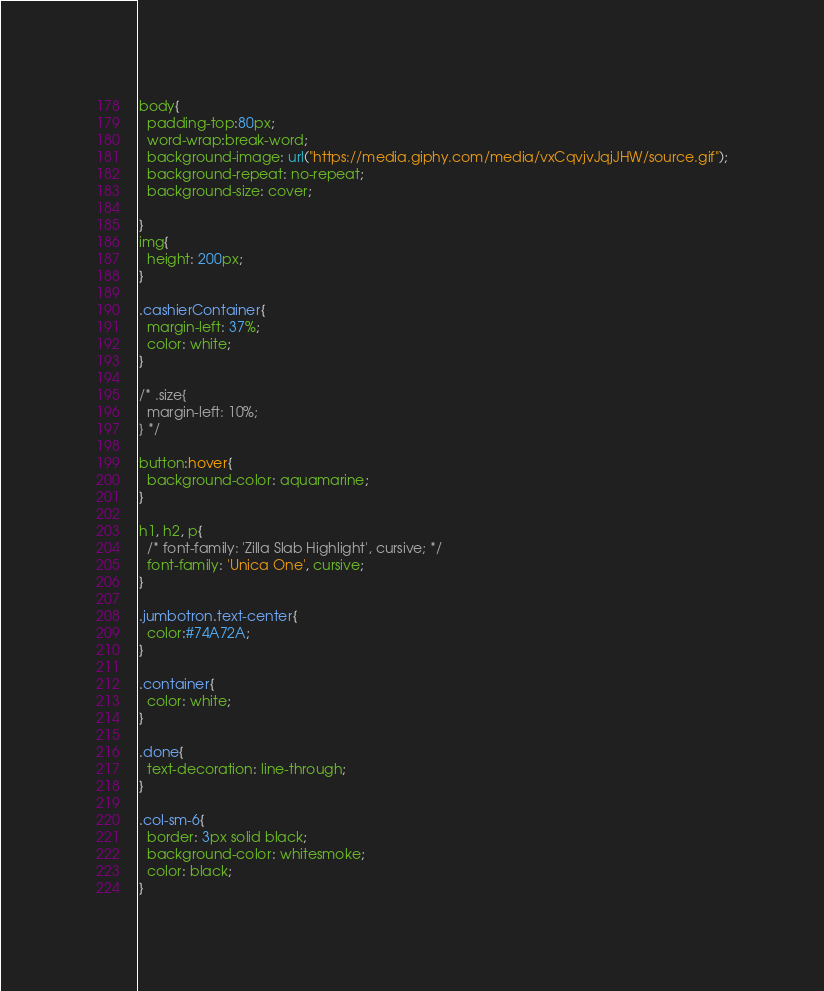<code> <loc_0><loc_0><loc_500><loc_500><_CSS_>body{
  padding-top:80px;
  word-wrap:break-word;
  background-image: url("https://media.giphy.com/media/vxCqvjvJqjJHW/source.gif");
  background-repeat: no-repeat;
  background-size: cover;

}
img{
  height: 200px;
}

.cashierContainer{
  margin-left: 37%;
  color: white;
}

/* .size{
  margin-left: 10%;
} */

button:hover{
  background-color: aquamarine;
}

h1, h2, p{
  /* font-family: 'Zilla Slab Highlight', cursive; */
  font-family: 'Unica One', cursive;
}

.jumbotron.text-center{
  color:#74A72A;
}

.container{
  color: white;
}

.done{
  text-decoration: line-through;
}

.col-sm-6{
  border: 3px solid black;
  background-color: whitesmoke;
  color: black;
}






</code> 